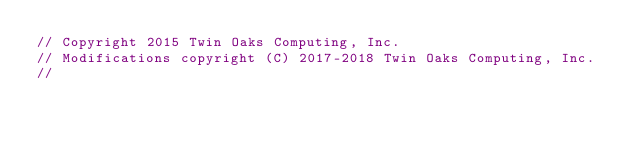Convert code to text. <code><loc_0><loc_0><loc_500><loc_500><_C++_>// Copyright 2015 Twin Oaks Computing, Inc.
// Modifications copyright (C) 2017-2018 Twin Oaks Computing, Inc.
//</code> 